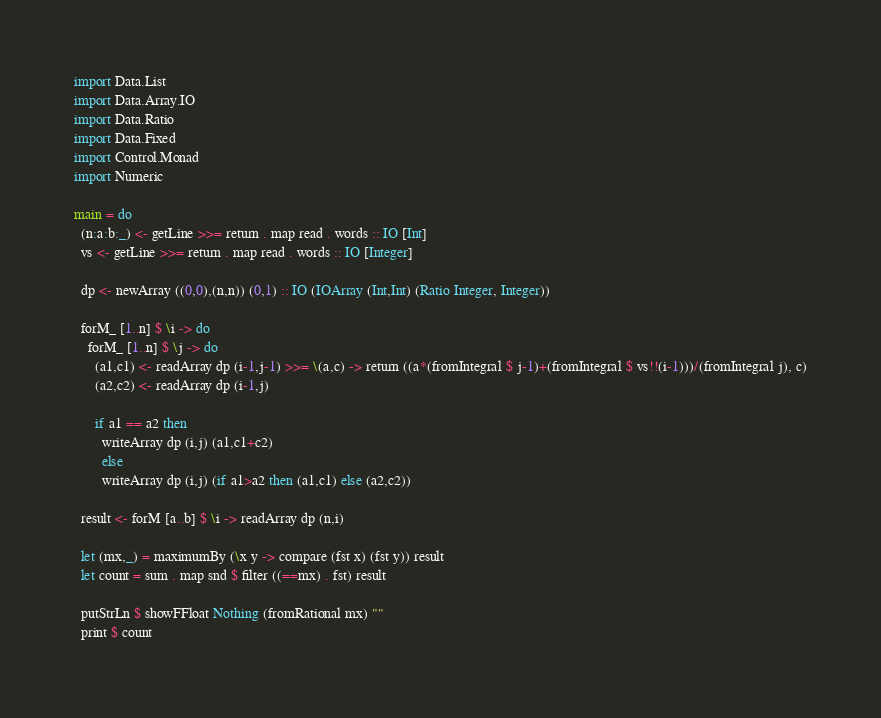Convert code to text. <code><loc_0><loc_0><loc_500><loc_500><_Haskell_>import Data.List
import Data.Array.IO
import Data.Ratio
import Data.Fixed
import Control.Monad
import Numeric

main = do
  (n:a:b:_) <- getLine >>= return . map read . words :: IO [Int]
  vs <- getLine >>= return . map read . words :: IO [Integer]

  dp <- newArray ((0,0),(n,n)) (0,1) :: IO (IOArray (Int,Int) (Ratio Integer, Integer))

  forM_ [1..n] $ \i -> do
    forM_ [1..n] $ \j -> do
      (a1,c1) <- readArray dp (i-1,j-1) >>= \(a,c) -> return ((a*(fromIntegral $ j-1)+(fromIntegral $ vs!!(i-1)))/(fromIntegral j), c)
      (a2,c2) <- readArray dp (i-1,j)

      if a1 == a2 then
        writeArray dp (i,j) (a1,c1+c2)
        else
        writeArray dp (i,j) (if a1>a2 then (a1,c1) else (a2,c2))
        
  result <- forM [a..b] $ \i -> readArray dp (n,i)

  let (mx,_) = maximumBy (\x y -> compare (fst x) (fst y)) result
  let count = sum . map snd $ filter ((==mx) . fst) result

  putStrLn $ showFFloat Nothing (fromRational mx) ""
  print $ count
</code> 